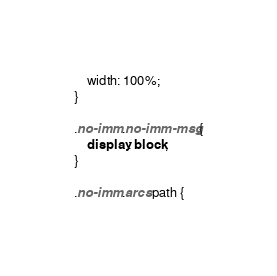<code> <loc_0><loc_0><loc_500><loc_500><_CSS_>	width: 100%;
}

.no-imm .no-imm-msg {
	display: block;
}

.no-imm .arcs path {</code> 